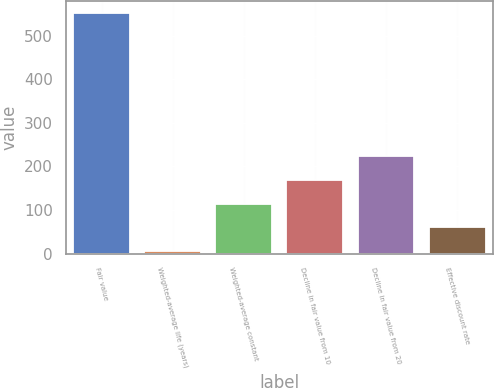Convert chart. <chart><loc_0><loc_0><loc_500><loc_500><bar_chart><fcel>Fair value<fcel>Weighted-average life (years)<fcel>Weighted-average constant<fcel>Decline in fair value from 10<fcel>Decline in fair value from 20<fcel>Effective discount rate<nl><fcel>552<fcel>5.3<fcel>114.64<fcel>169.31<fcel>223.98<fcel>59.97<nl></chart> 